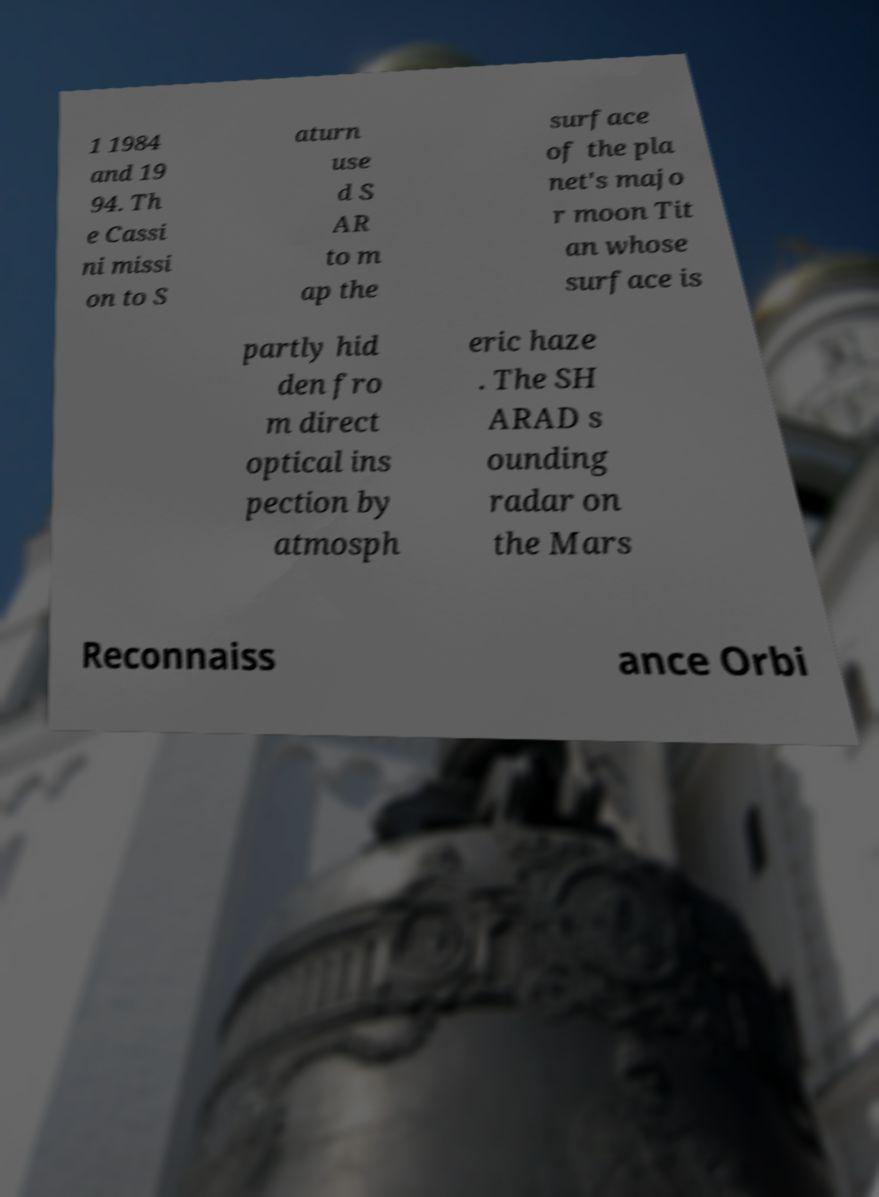What messages or text are displayed in this image? I need them in a readable, typed format. 1 1984 and 19 94. Th e Cassi ni missi on to S aturn use d S AR to m ap the surface of the pla net's majo r moon Tit an whose surface is partly hid den fro m direct optical ins pection by atmosph eric haze . The SH ARAD s ounding radar on the Mars Reconnaiss ance Orbi 